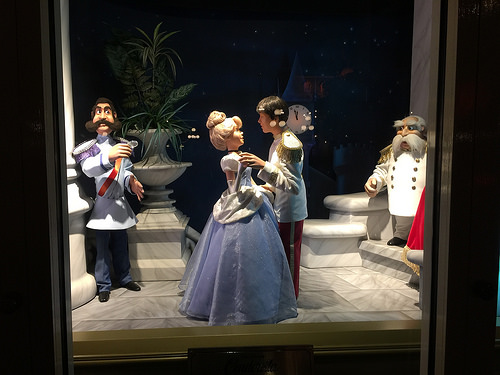<image>
Is there a lady next to the man? No. The lady is not positioned next to the man. They are located in different areas of the scene. 